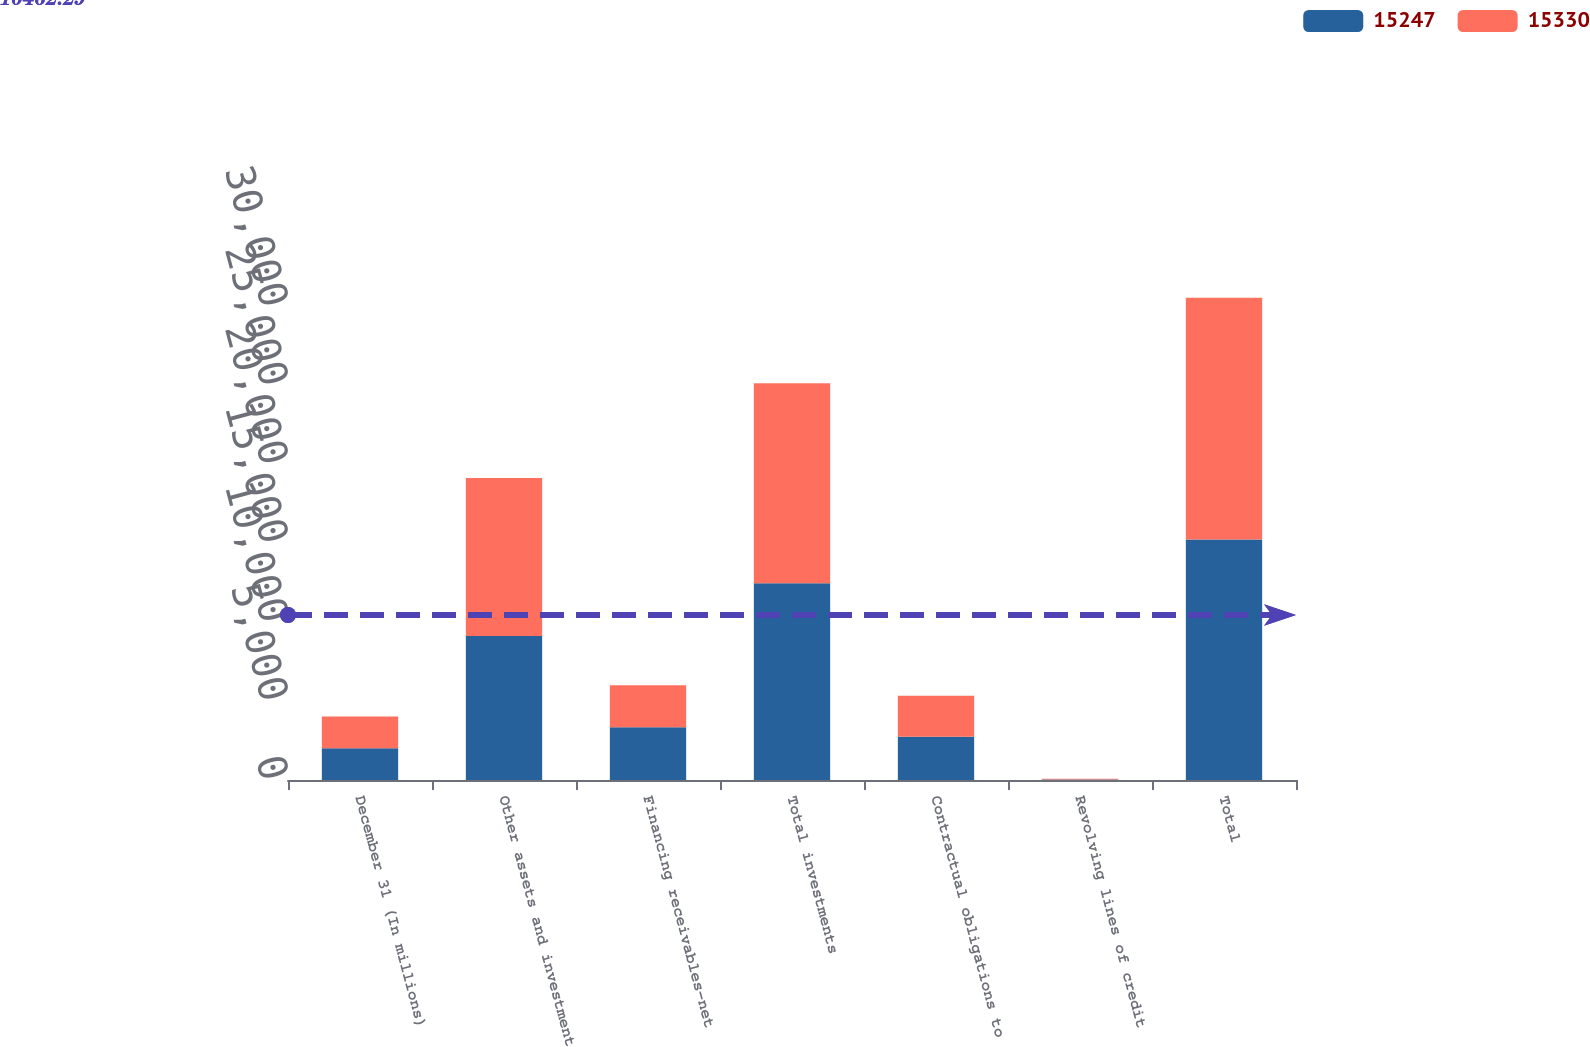Convert chart. <chart><loc_0><loc_0><loc_500><loc_500><stacked_bar_chart><ecel><fcel>December 31 (In millions)<fcel>Other assets and investment<fcel>Financing receivables-net<fcel>Total investments<fcel>Contractual obligations to<fcel>Revolving lines of credit<fcel>Total<nl><fcel>15247<fcel>2013<fcel>9129<fcel>3346<fcel>12475<fcel>2741<fcel>31<fcel>15247<nl><fcel>15330<fcel>2012<fcel>10027<fcel>2654<fcel>12681<fcel>2608<fcel>41<fcel>15330<nl></chart> 